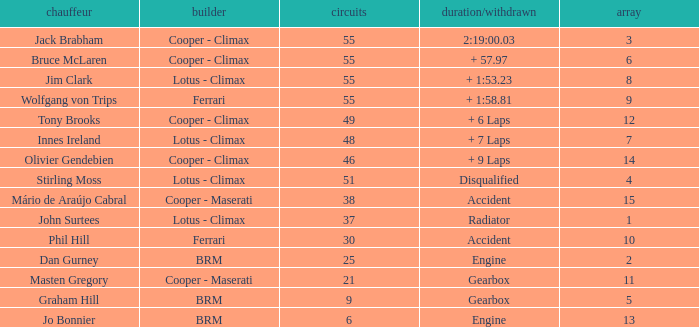Tell me the laps for 3 grids 55.0. Would you be able to parse every entry in this table? {'header': ['chauffeur', 'builder', 'circuits', 'duration/withdrawn', 'array'], 'rows': [['Jack Brabham', 'Cooper - Climax', '55', '2:19:00.03', '3'], ['Bruce McLaren', 'Cooper - Climax', '55', '+ 57.97', '6'], ['Jim Clark', 'Lotus - Climax', '55', '+ 1:53.23', '8'], ['Wolfgang von Trips', 'Ferrari', '55', '+ 1:58.81', '9'], ['Tony Brooks', 'Cooper - Climax', '49', '+ 6 Laps', '12'], ['Innes Ireland', 'Lotus - Climax', '48', '+ 7 Laps', '7'], ['Olivier Gendebien', 'Cooper - Climax', '46', '+ 9 Laps', '14'], ['Stirling Moss', 'Lotus - Climax', '51', 'Disqualified', '4'], ['Mário de Araújo Cabral', 'Cooper - Maserati', '38', 'Accident', '15'], ['John Surtees', 'Lotus - Climax', '37', 'Radiator', '1'], ['Phil Hill', 'Ferrari', '30', 'Accident', '10'], ['Dan Gurney', 'BRM', '25', 'Engine', '2'], ['Masten Gregory', 'Cooper - Maserati', '21', 'Gearbox', '11'], ['Graham Hill', 'BRM', '9', 'Gearbox', '5'], ['Jo Bonnier', 'BRM', '6', 'Engine', '13']]} 